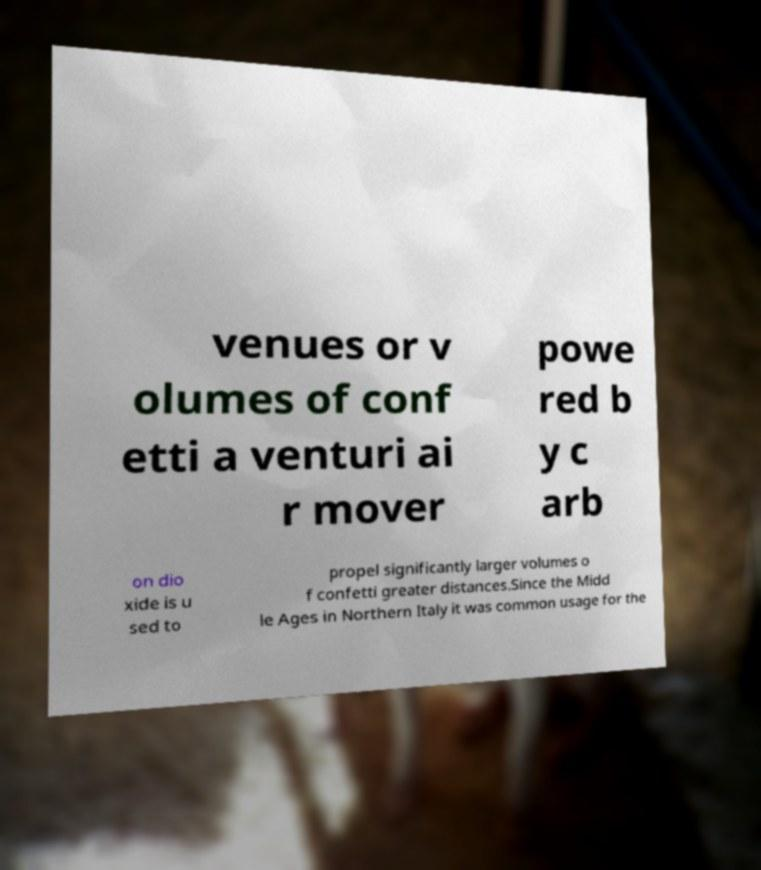Can you accurately transcribe the text from the provided image for me? venues or v olumes of conf etti a venturi ai r mover powe red b y c arb on dio xide is u sed to propel significantly larger volumes o f confetti greater distances.Since the Midd le Ages in Northern Italy it was common usage for the 